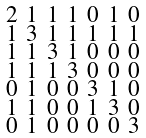<formula> <loc_0><loc_0><loc_500><loc_500>\begin{smallmatrix} 2 & 1 & 1 & 1 & 0 & 1 & 0 \\ 1 & 3 & 1 & 1 & 1 & 1 & 1 \\ 1 & 1 & 3 & 1 & 0 & 0 & 0 \\ 1 & 1 & 1 & 3 & 0 & 0 & 0 \\ 0 & 1 & 0 & 0 & 3 & 1 & 0 \\ 1 & 1 & 0 & 0 & 1 & 3 & 0 \\ 0 & 1 & 0 & 0 & 0 & 0 & 3 \end{smallmatrix}</formula> 